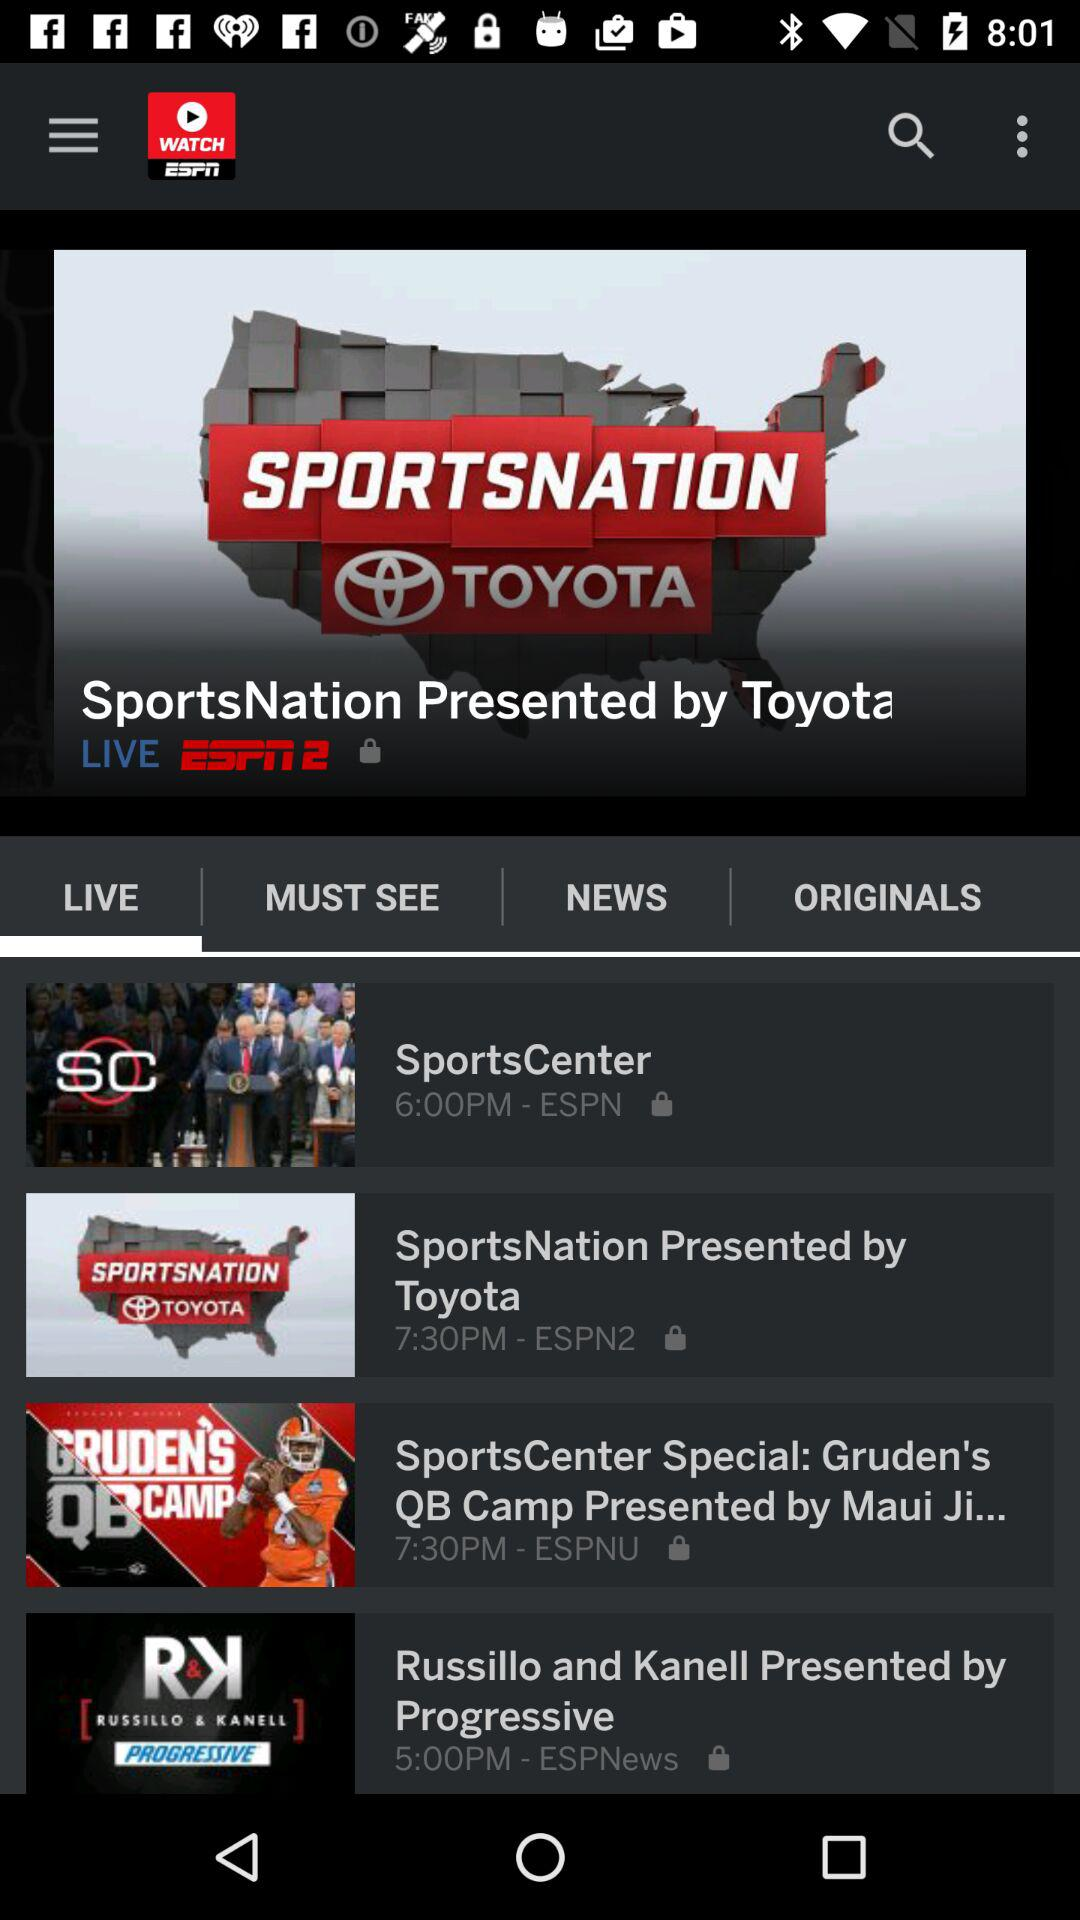Which tab has been selected? The selected tab is "LIVE". 